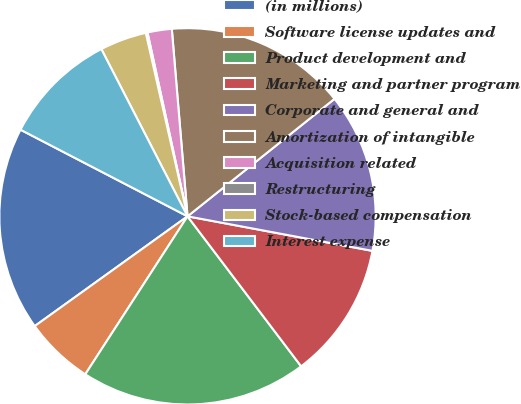<chart> <loc_0><loc_0><loc_500><loc_500><pie_chart><fcel>(in millions)<fcel>Software license updates and<fcel>Product development and<fcel>Marketing and partner program<fcel>Corporate and general and<fcel>Amortization of intangible<fcel>Acquisition related<fcel>Restructuring<fcel>Stock-based compensation<fcel>Interest expense<nl><fcel>17.53%<fcel>5.94%<fcel>19.46%<fcel>11.74%<fcel>13.67%<fcel>15.6%<fcel>2.08%<fcel>0.15%<fcel>4.01%<fcel>9.81%<nl></chart> 